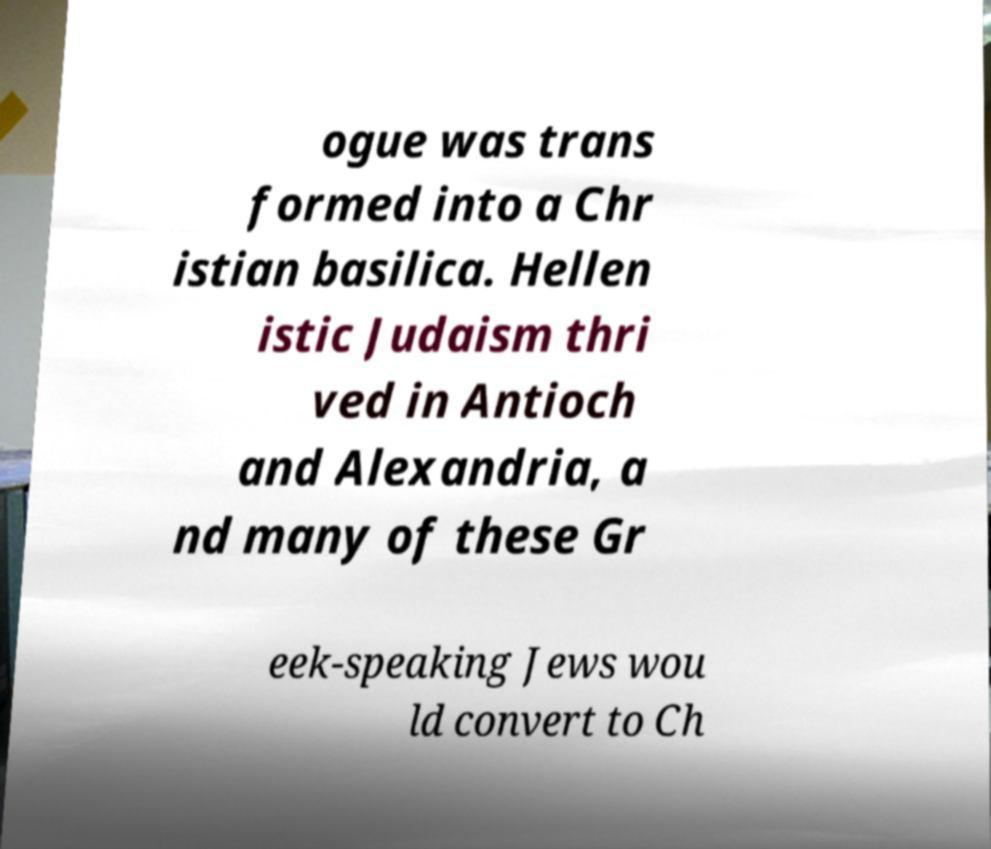Please read and relay the text visible in this image. What does it say? ogue was trans formed into a Chr istian basilica. Hellen istic Judaism thri ved in Antioch and Alexandria, a nd many of these Gr eek-speaking Jews wou ld convert to Ch 